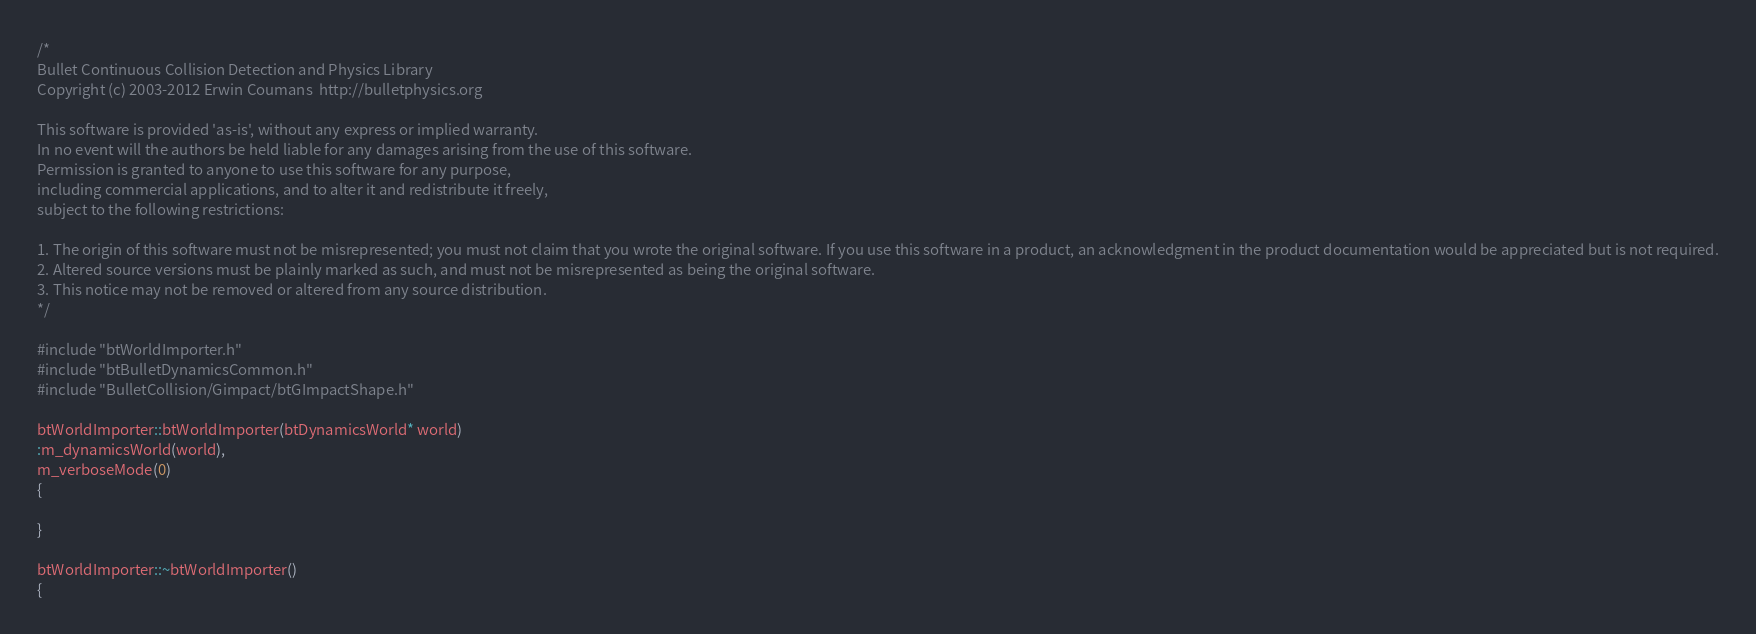<code> <loc_0><loc_0><loc_500><loc_500><_C++_>/*
Bullet Continuous Collision Detection and Physics Library
Copyright (c) 2003-2012 Erwin Coumans  http://bulletphysics.org

This software is provided 'as-is', without any express or implied warranty.
In no event will the authors be held liable for any damages arising from the use of this software.
Permission is granted to anyone to use this software for any purpose, 
including commercial applications, and to alter it and redistribute it freely, 
subject to the following restrictions:

1. The origin of this software must not be misrepresented; you must not claim that you wrote the original software. If you use this software in a product, an acknowledgment in the product documentation would be appreciated but is not required.
2. Altered source versions must be plainly marked as such, and must not be misrepresented as being the original software.
3. This notice may not be removed or altered from any source distribution.
*/

#include "btWorldImporter.h"
#include "btBulletDynamicsCommon.h"
#include "BulletCollision/Gimpact/btGImpactShape.h"

btWorldImporter::btWorldImporter(btDynamicsWorld* world)
:m_dynamicsWorld(world),
m_verboseMode(0)
{

}

btWorldImporter::~btWorldImporter()
{</code> 